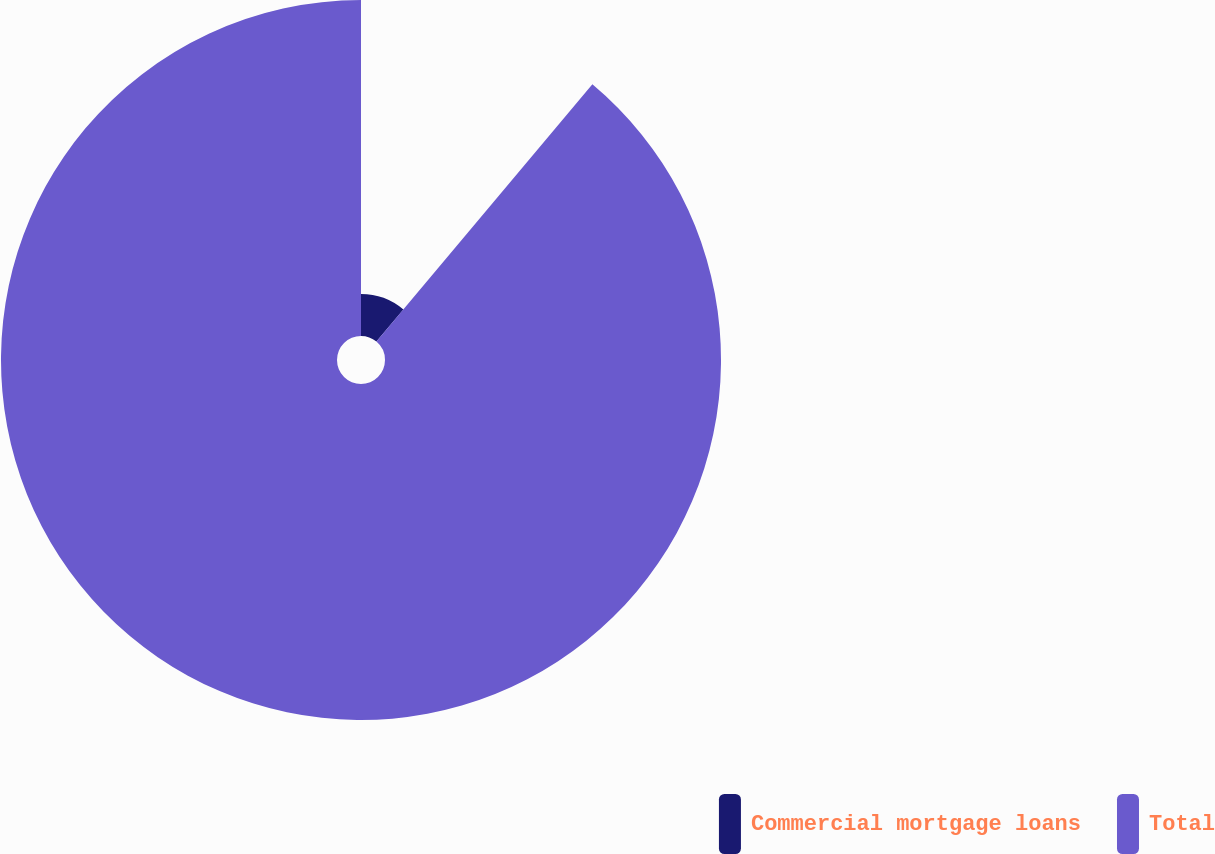Convert chart to OTSL. <chart><loc_0><loc_0><loc_500><loc_500><pie_chart><fcel>Commercial mortgage loans<fcel>Total<nl><fcel>11.11%<fcel>88.89%<nl></chart> 